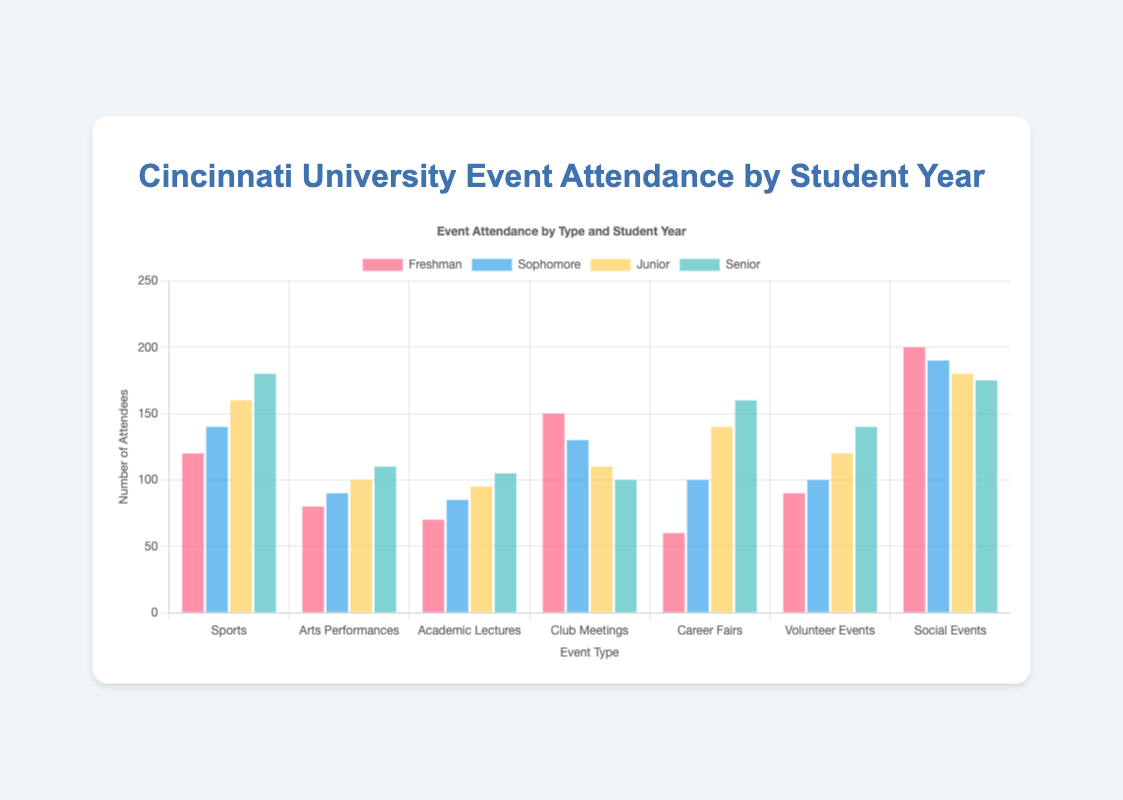Which event type has the highest attendance among Freshmen? To find the event type with the highest attendance among Freshmen, look at the Freshman bars for each event. The tallest bar represents the highest attendance. In this case, it's for Social Events.
Answer: Social Events What is the total attendance for Social Events across all years? Add the attendance numbers for Social Events across all student years: Freshman (200) + Sophomore (190) + Junior (180) + Senior (175) = 745.
Answer: 745 Which year has the highest average attendance across all event types? To find the average attendance for each year, add the attendance numbers for each event type and divide by the number of event types (7). Compare these averages:
- Freshman: (120 + 80 + 70 + 150 + 60 + 90 + 200) / 7 = 110
- Sophomore: (140 + 90 + 85 + 130 + 100 + 100 + 190) / 7 ≈ 119.29
- Junior: (160 + 100 + 95 + 110 + 140 + 120 + 180) / 7 ≈ 129.29
- Senior: (180 + 110 + 105 + 100 + 160 + 140 + 175) / 7 ≈ 138.57
Senior has the highest average.
Answer: Senior How does the attendance at Volunteer Events compare between Freshmen and Seniors? Look at the bars for Volunteer Events: Freshman (90) and Senior (140). Seniors have higher attendance.
Answer: Seniors Which event type has decreasing attendance as the student year progresses? We need to identify the event type where the attendance figure consistently reduces from Freshman to Senior. For Club Meetings, the attendance reduces from 150 (Freshman) to 130 (Sophomore) to 110 (Junior) to 100 (Senior).
Answer: Club Meetings By how much does the attendance at Career Fairs for Seniors exceed that of Freshmen? Subtract the Freshman attendance from the Senior attendance for Career Fairs: 160 - 60 = 100.
Answer: 100 Which student year has the most balanced attendance across all event types? To determine the most balanced attendance, visually inspect the bars for each year and check for minimal variation in height:
- Freshman: Significant variation (e.g., 200 for Social Events vs. 60 for Career Fairs).
- Sophomore: Noticeable variation (e.g., 190 for Social Events vs. 85 for Academic Lectures).
- Junior: Significant variation (180 for Social Events vs. 95 for Academic Lectures).
- Senior: Slightly less variation (175 for Social Events vs. 100 for Club Meetings).
Senior appears most balanced, though slightly more than others.
Answer: Senior 